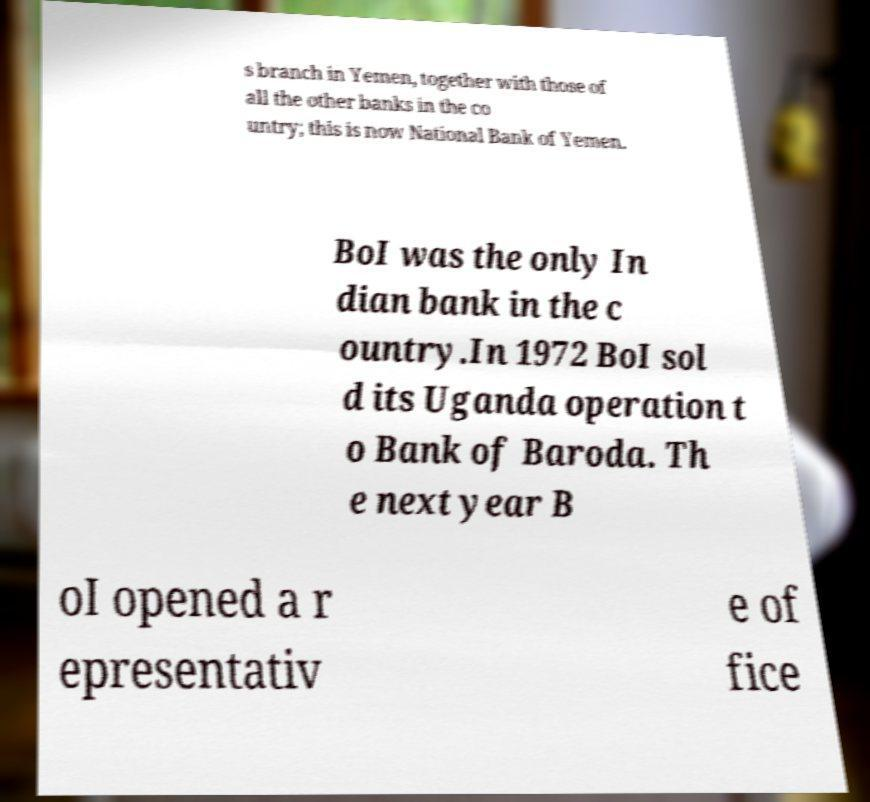Could you assist in decoding the text presented in this image and type it out clearly? s branch in Yemen, together with those of all the other banks in the co untry; this is now National Bank of Yemen. BoI was the only In dian bank in the c ountry.In 1972 BoI sol d its Uganda operation t o Bank of Baroda. Th e next year B oI opened a r epresentativ e of fice 